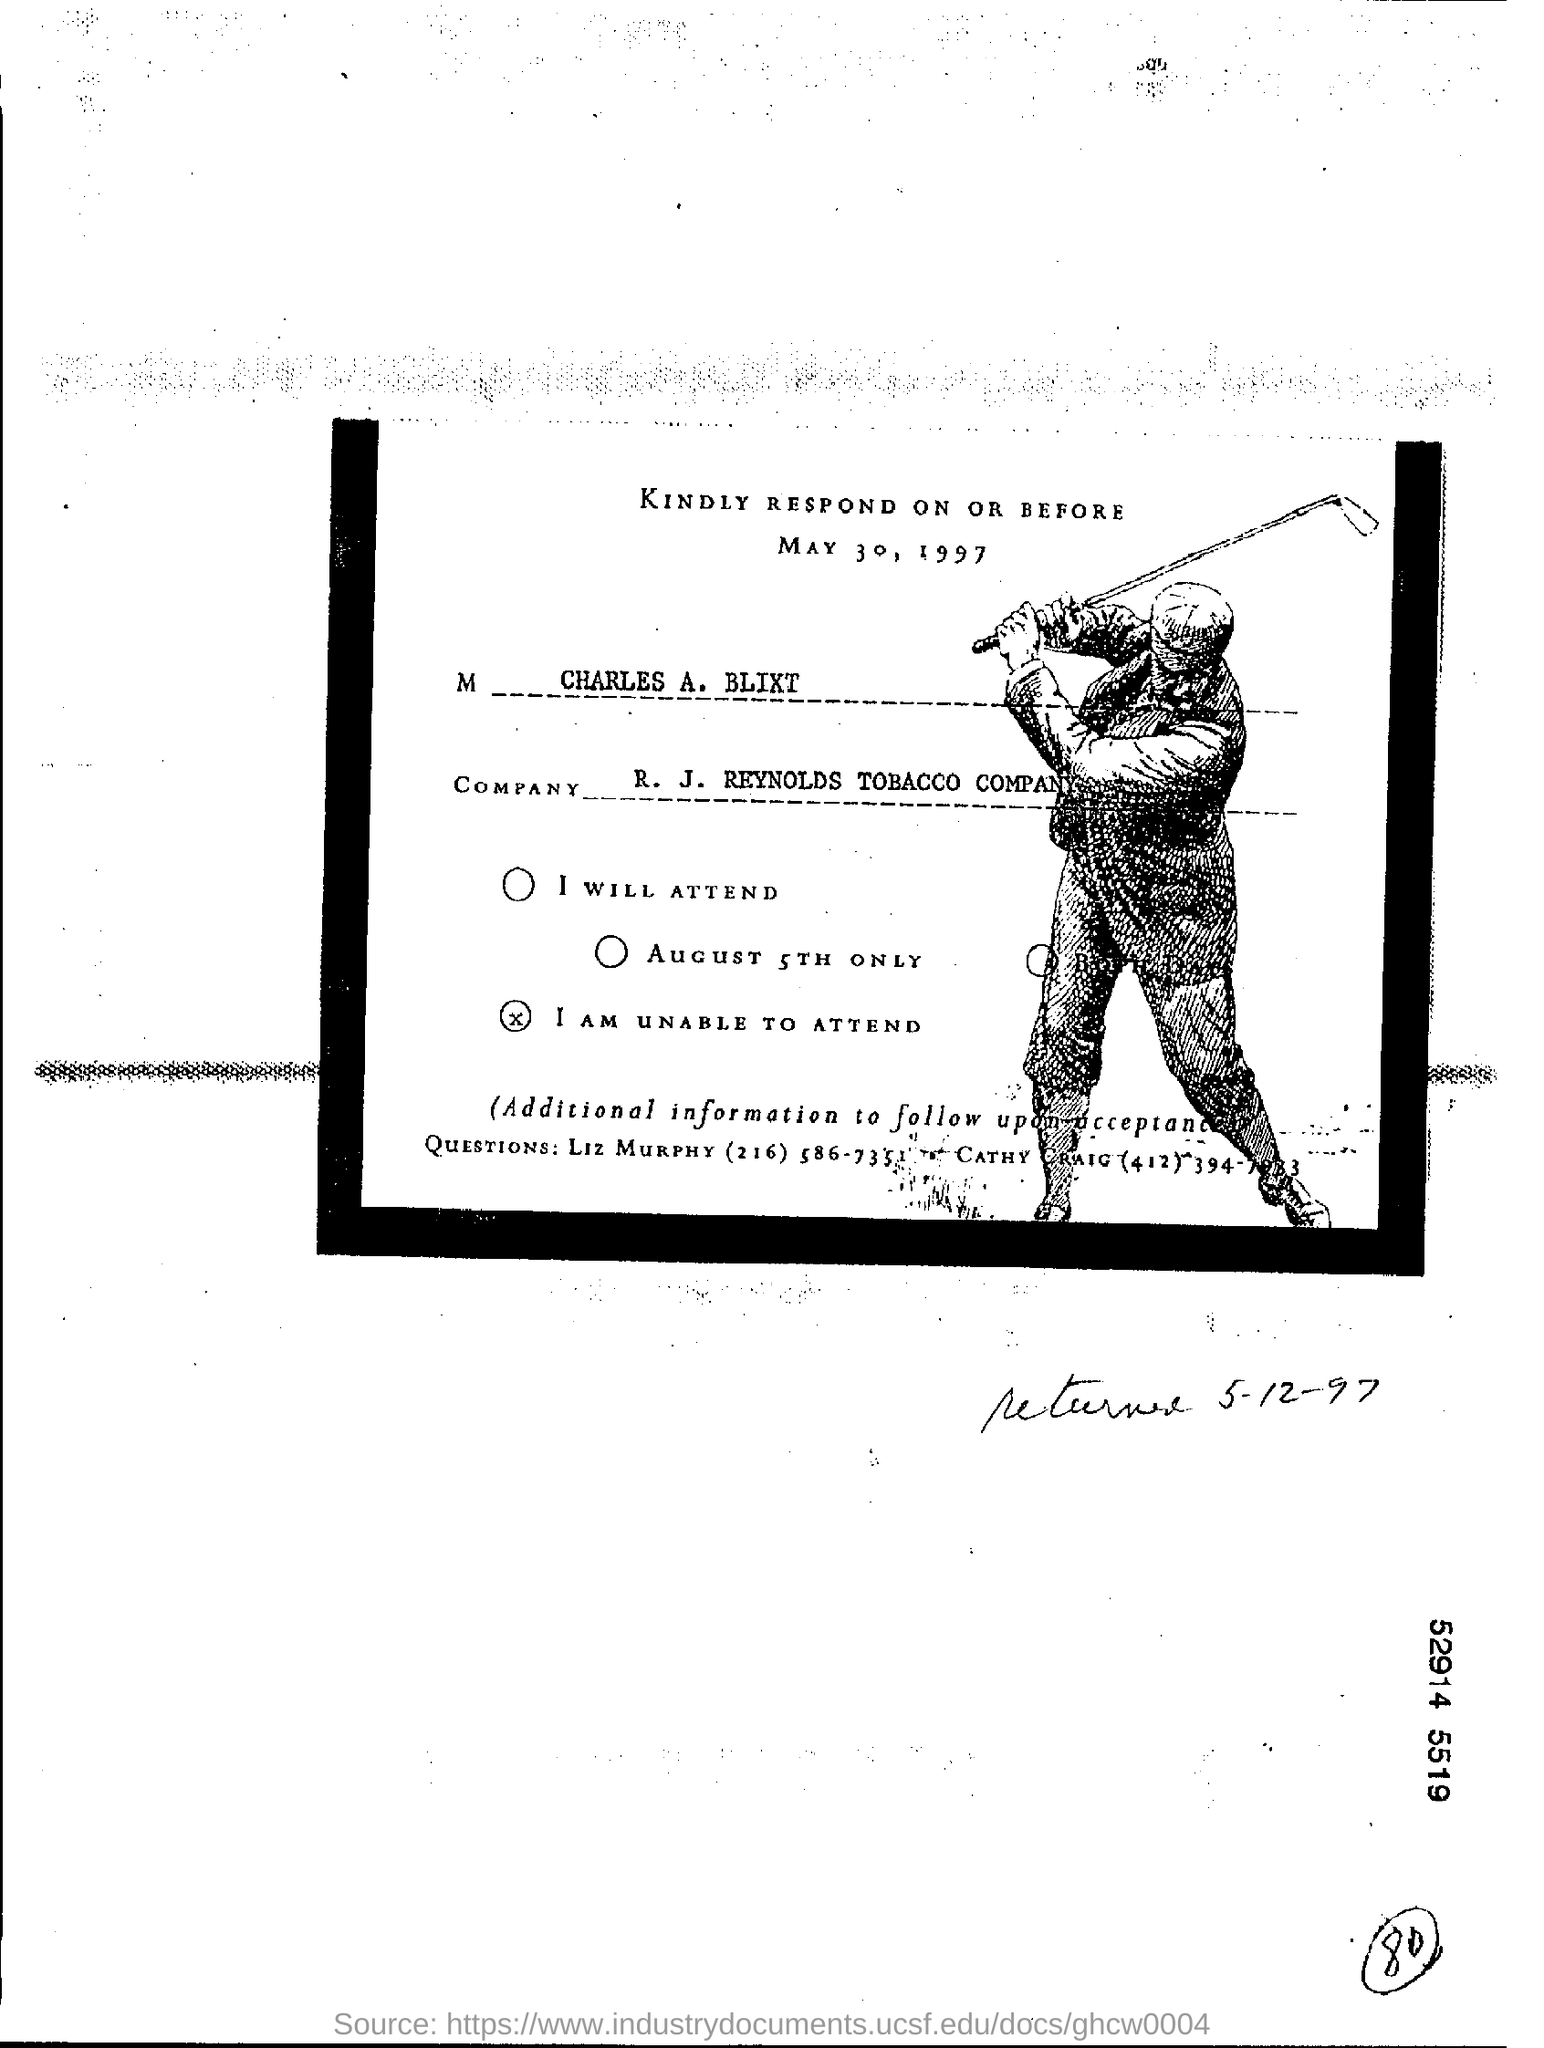Highlight a few significant elements in this photo. I, [Your Name], am a smoker of R. J. Reynolds Tobacco Company products. The last day to respond is May 30, 1997. Liz Murphy is the contact person for any queries. 